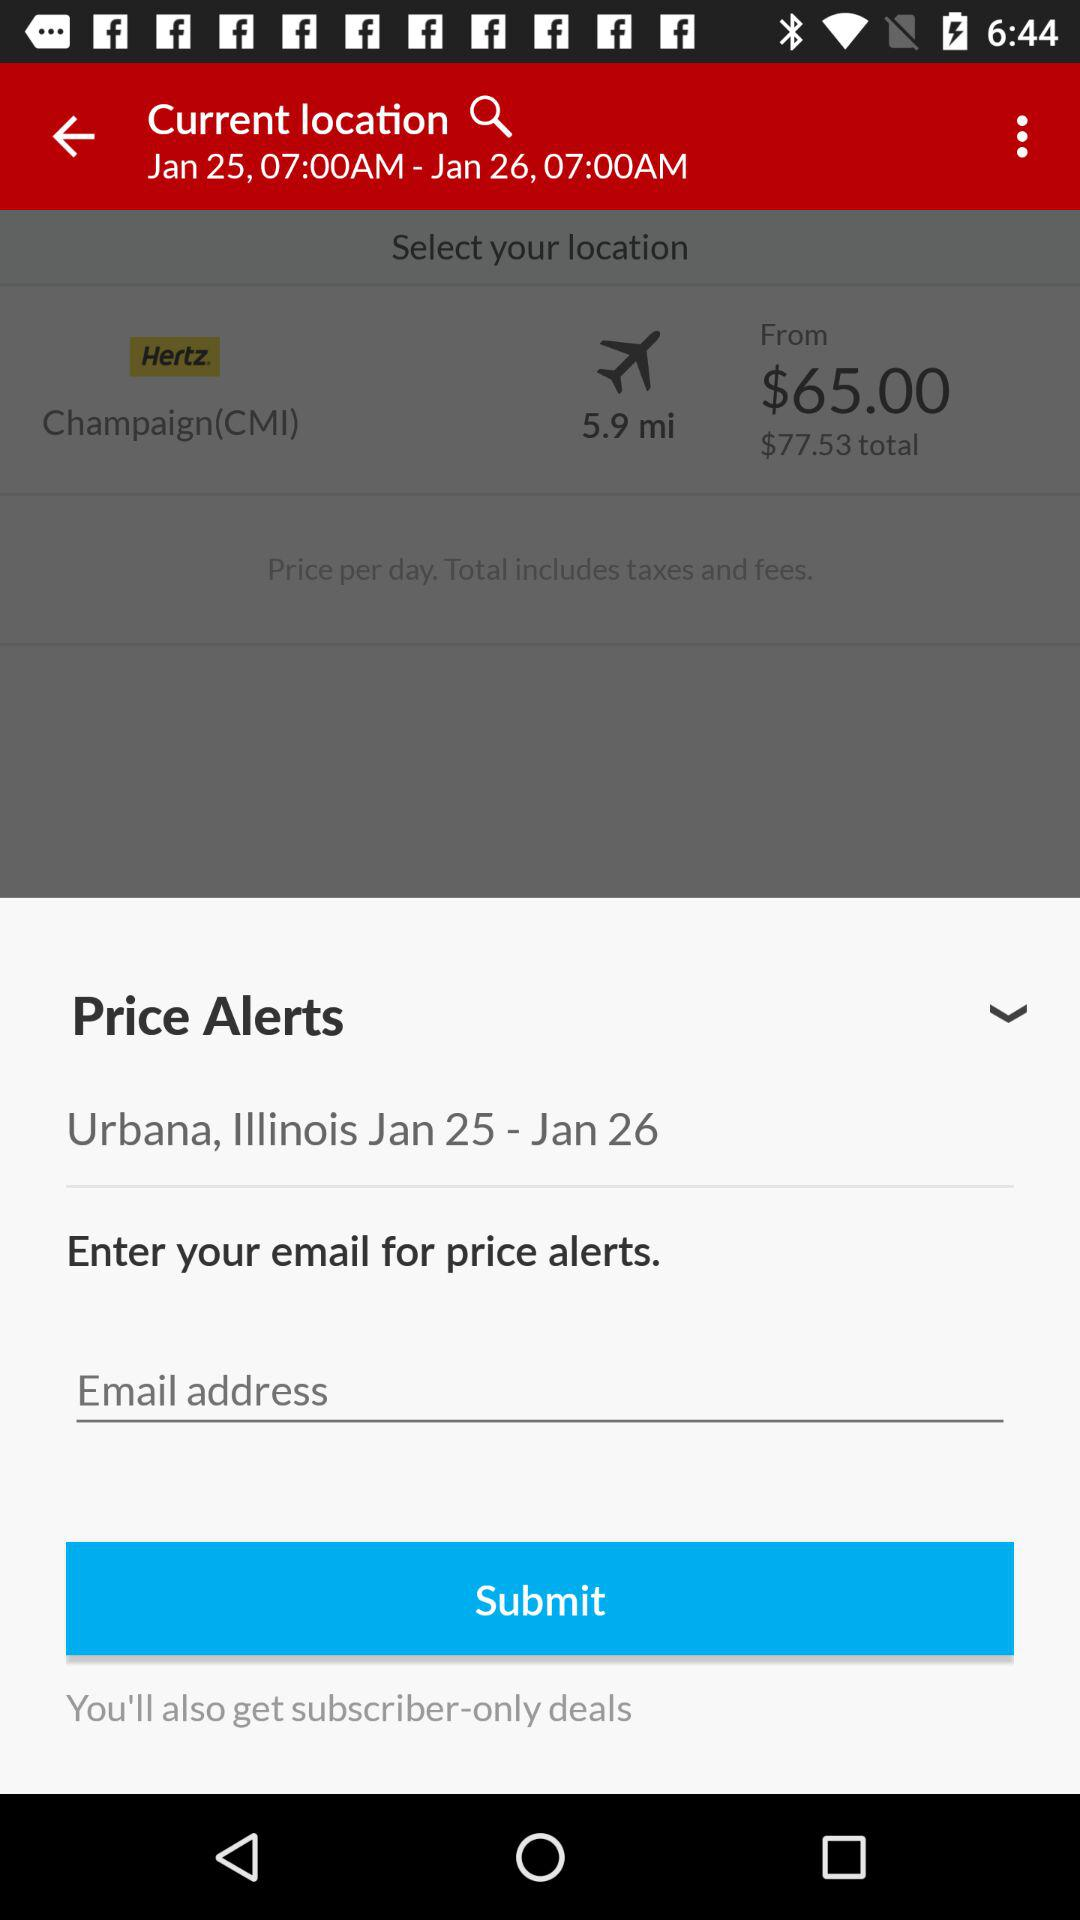What is the date? The dates are January 25 and 26. 